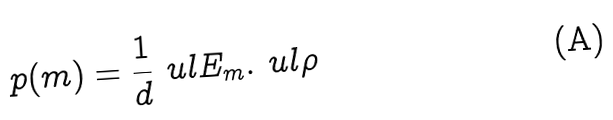Convert formula to latex. <formula><loc_0><loc_0><loc_500><loc_500>p ( m ) = \frac { 1 } { d } \ u l { E _ { m } } . \ u l { \rho }</formula> 